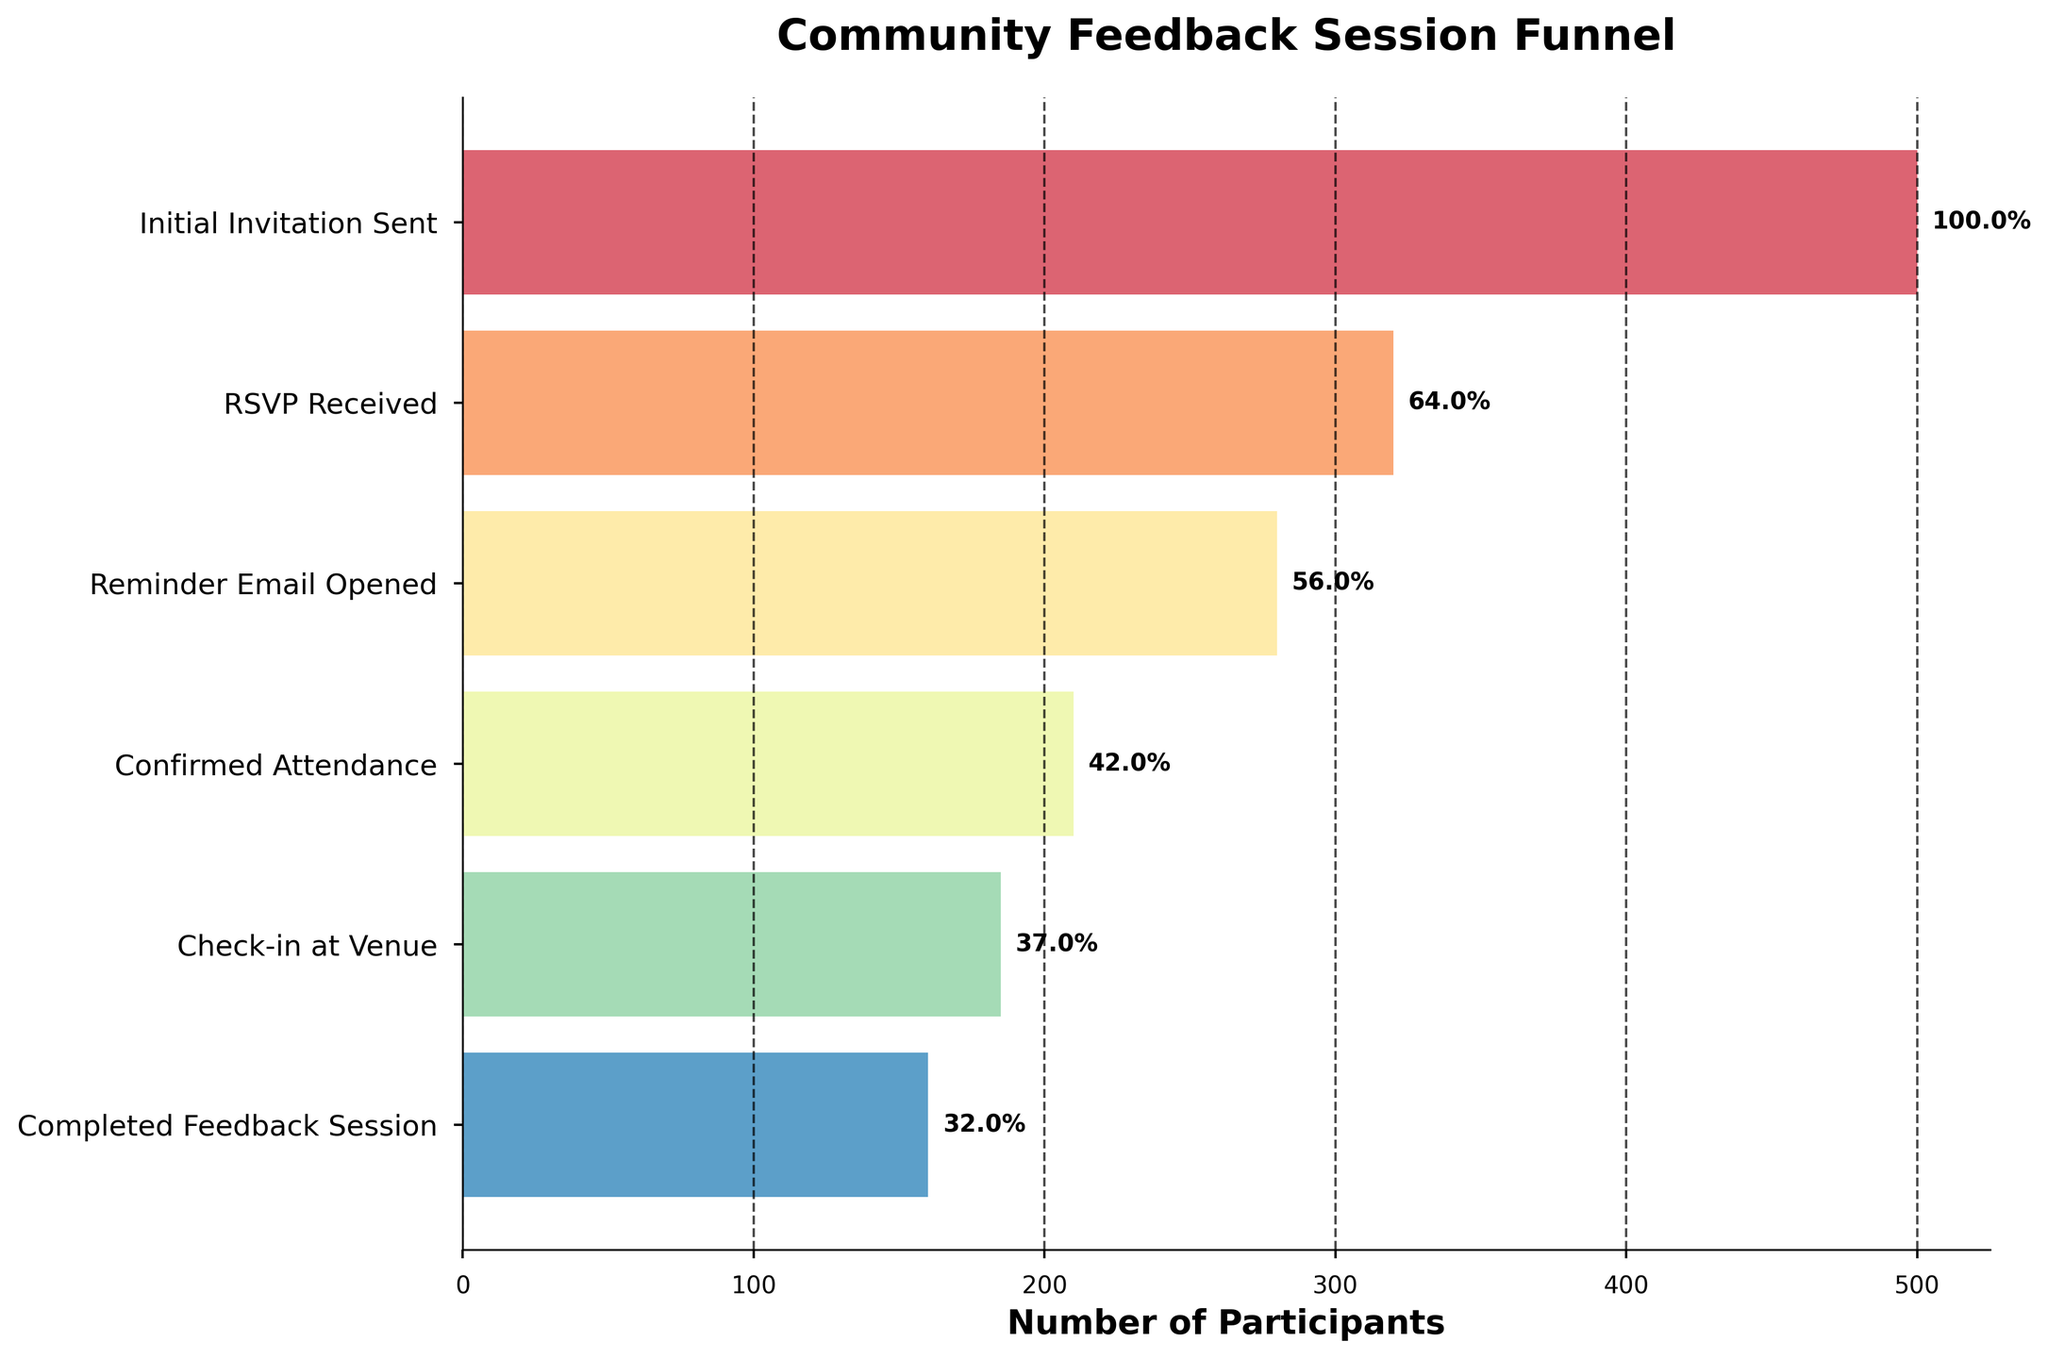What is the title of the chart? The title is usually located at the top of the chart, and in this case, it reads "Community Feedback Session Funnel".
Answer: "Community Feedback Session Funnel" How many stages are there in the funnel? The stages are listed on the y-axis of the chart, and each unique label represents a stage in the funnel. Counting these labels gives the total number of stages.
Answer: 6 What is the percentage of participants that completed the feedback session relative to the initial invitation sent? First, note the number of participants for both stages: 160 for "Completed Feedback Session" and 500 for "Initial Invitation Sent". Then, calculate the percentage: (160 / 500) * 100.
Answer: 32.0% Which stage had the largest drop in participant numbers? By examining the differences in the number of participants between consecutive stages, it can be seen that the largest drop is from "RSVP Received" to "Reminder Email Opened" (320 to 280).
Answer: RSVP Received to Reminder Email Opened What percentage of participants confirmed their attendance after opening the reminder email? Note the participant numbers for "Confirmed Attendance" (210) and "Reminder Email Opened" (280). Calculate the percentage: (210 / 280) * 100.
Answer: 75.0% How many participants checked in at the venue but did not complete the feedback session? Subtract the number of participants in "Completed Feedback Session" (160) from those in "Check-in at Venue" (185).
Answer: 25 Compare the number of participants who confirmed attendance to those who RSVP'd. Which stage had more participants, and by how much? Compare the figures: 320 for "RSVP Received" and 210 for "Confirmed Attendance". Subtract the smaller from the larger: 320 - 210.
Answer: RSVP Received by 110 What is the difference in participant numbers between the initial invitation sent and the confirmed attendance? Subtract the number of participants in "Confirmed Attendance" (210) from those in "Initial Invitation Sent" (500).
Answer: 290 What is the participation rate from the initial invitation to the check-in at the venue? Note the participant numbers for "Check-in at Venue" (185) and "Initial Invitation Sent" (500). Calculate the rate: (185 / 500) * 100.
Answer: 37.0% Which stage shows nearly half the number of participants compared to the initial invitation? Identify stages where the number of participants is roughly half of the initial 500. The closest is "Check-in at Venue" with 185 participants, which is approximately 37% of the initial number.
Answer: Check-in at Venue 